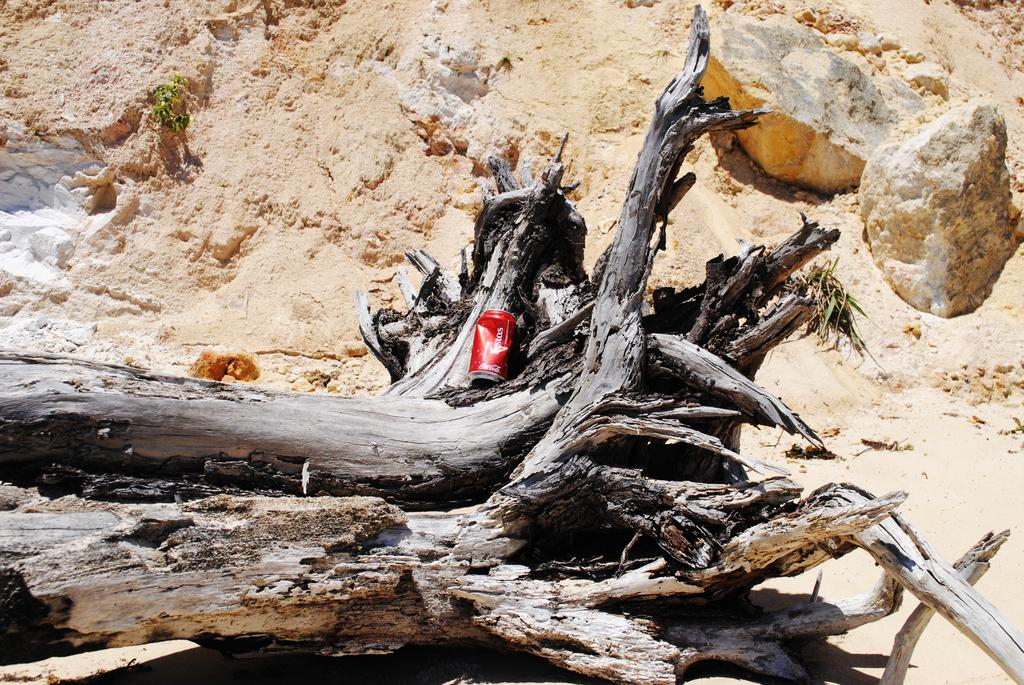What is placed on top of the log in the image? There is a tin on the log. What type of material can be seen in the background of the image? Soil is visible in the background of the image. Are there any other objects in the background of the image? Yes, there are two stones in the background of the image. What type of furniture can be seen in the image? There is no furniture present in the image. What record was set by the achiever in the image? There is no achiever or record mentioned in the image. 